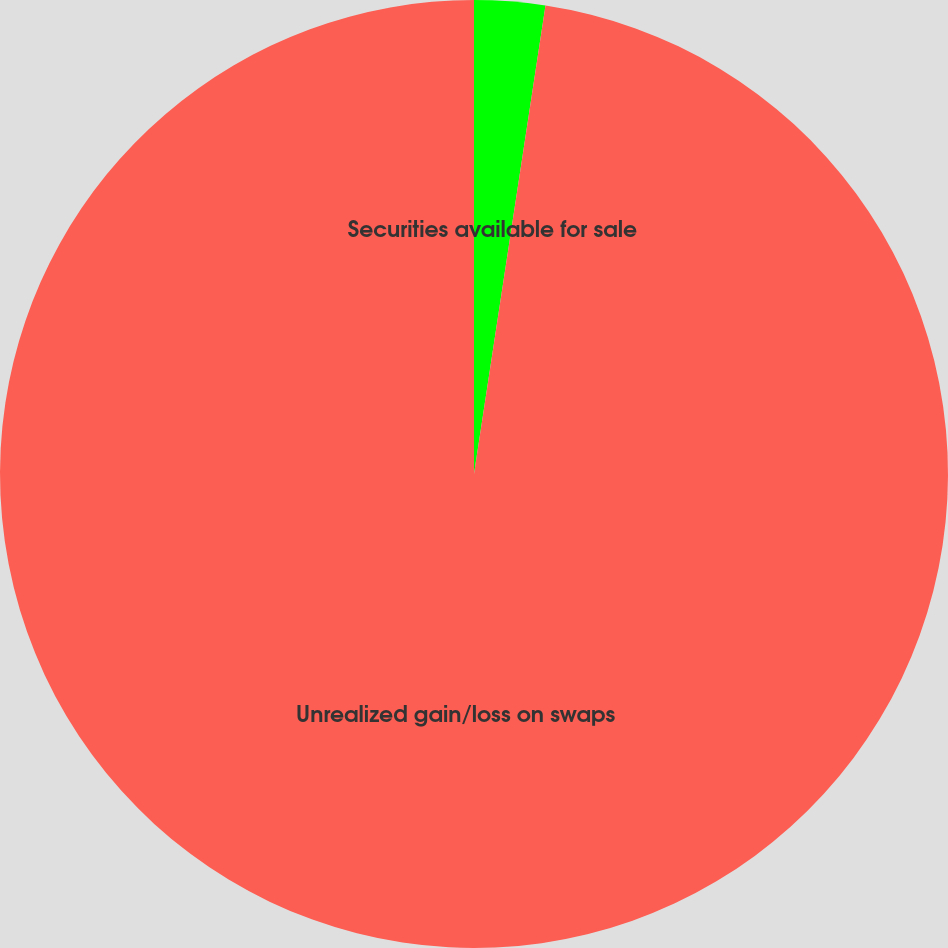<chart> <loc_0><loc_0><loc_500><loc_500><pie_chart><fcel>Securities available for sale<fcel>Unrealized gain/loss on swaps<nl><fcel>2.41%<fcel>97.59%<nl></chart> 